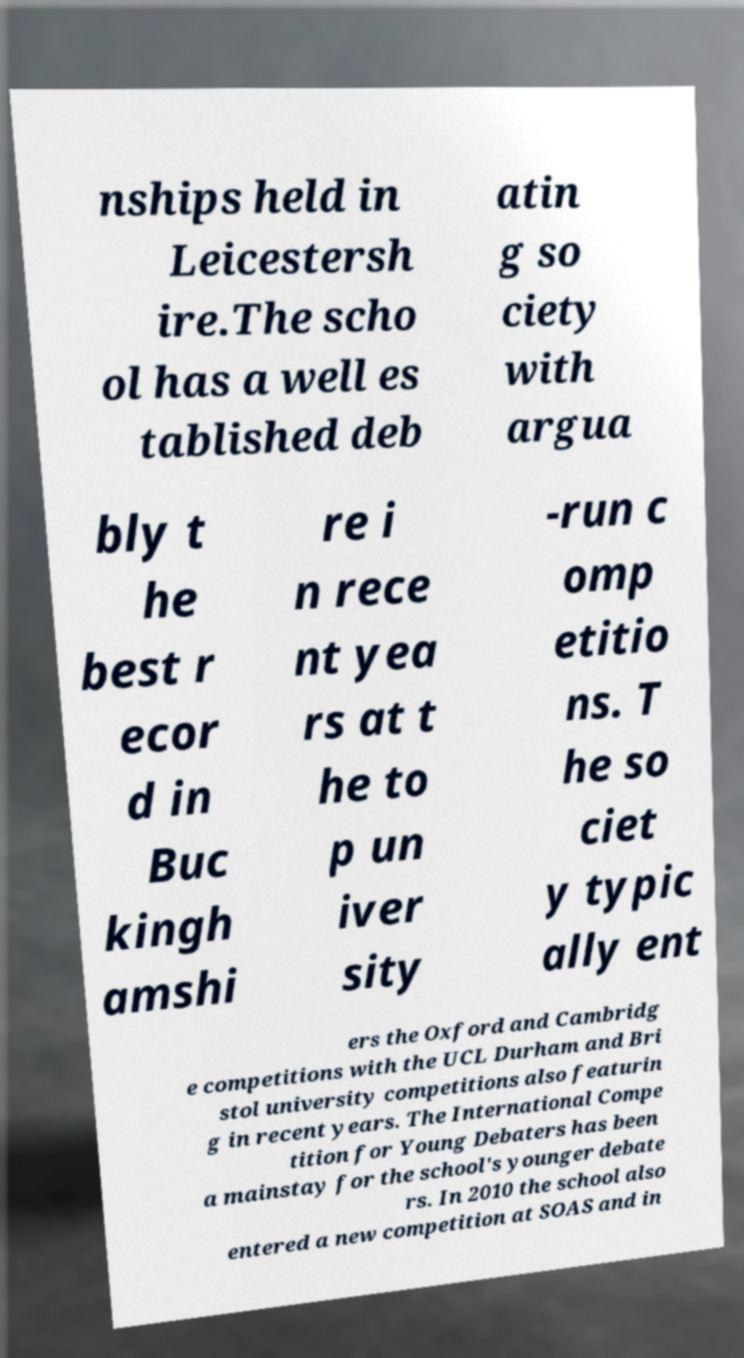Could you extract and type out the text from this image? nships held in Leicestersh ire.The scho ol has a well es tablished deb atin g so ciety with argua bly t he best r ecor d in Buc kingh amshi re i n rece nt yea rs at t he to p un iver sity -run c omp etitio ns. T he so ciet y typic ally ent ers the Oxford and Cambridg e competitions with the UCL Durham and Bri stol university competitions also featurin g in recent years. The International Compe tition for Young Debaters has been a mainstay for the school's younger debate rs. In 2010 the school also entered a new competition at SOAS and in 